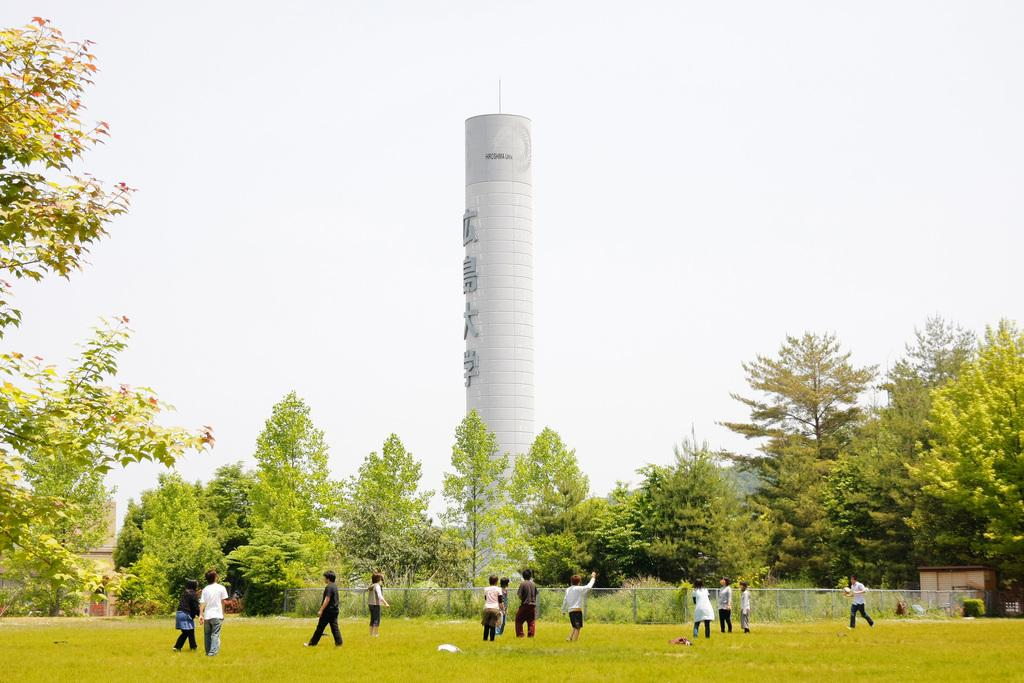How many people are in the image? There is a group of people standing in the image. What can be seen in the background of the image? There is railing, trees with green color, and a tower visible in the background of the image. What is the color of the sky in the image? The sky is white in color. How many sheep are visible on the island in the image? There is no island or sheep present in the image. What type of seat is available for the people in the image? The provided facts do not mention any seats for the people in the image. 